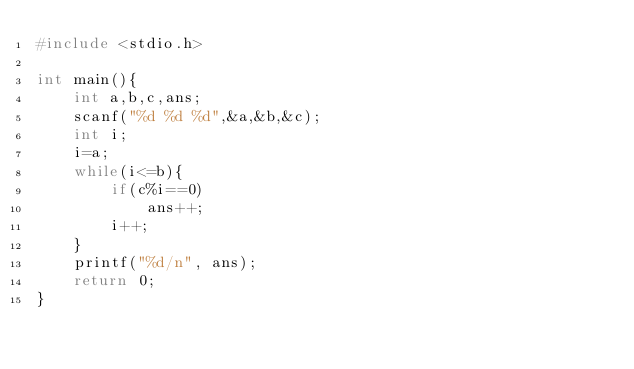Convert code to text. <code><loc_0><loc_0><loc_500><loc_500><_C_>#include <stdio.h>

int main(){
    int a,b,c,ans;
    scanf("%d %d %d",&a,&b,&c);
    int i;
    i=a;
    while(i<=b){
        if(c%i==0)
            ans++;
        i++;
    }
    printf("%d/n", ans);
    return 0;
}</code> 